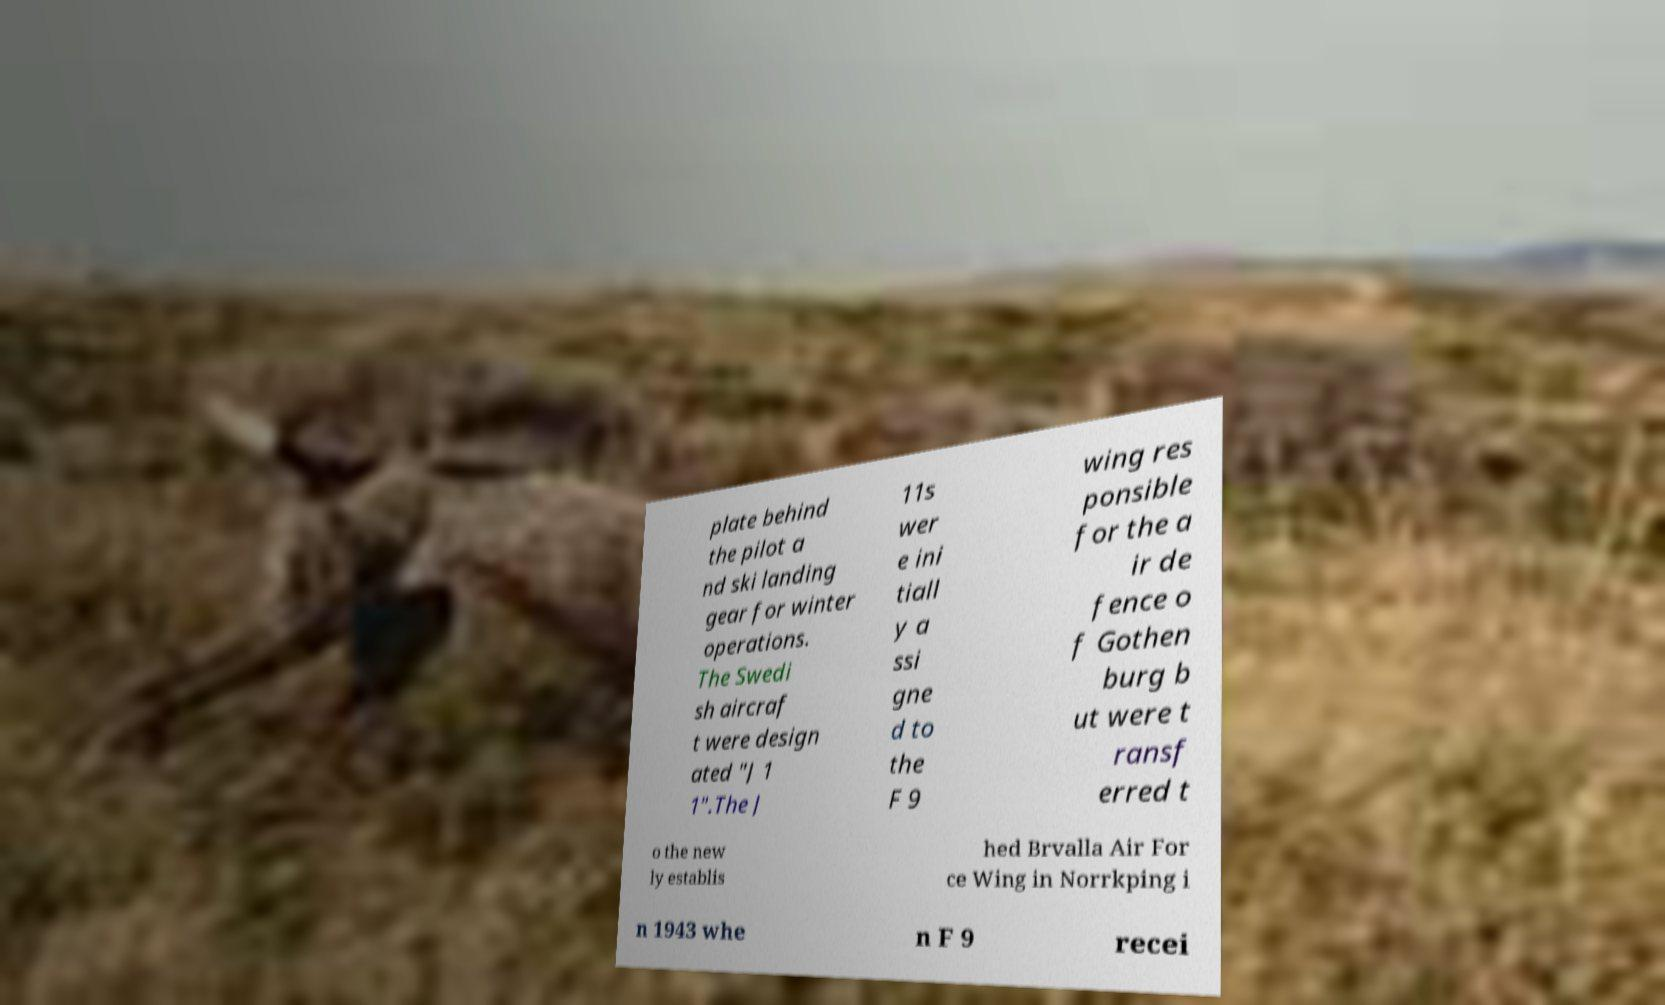I need the written content from this picture converted into text. Can you do that? plate behind the pilot a nd ski landing gear for winter operations. The Swedi sh aircraf t were design ated "J 1 1".The J 11s wer e ini tiall y a ssi gne d to the F 9 wing res ponsible for the a ir de fence o f Gothen burg b ut were t ransf erred t o the new ly establis hed Brvalla Air For ce Wing in Norrkping i n 1943 whe n F 9 recei 